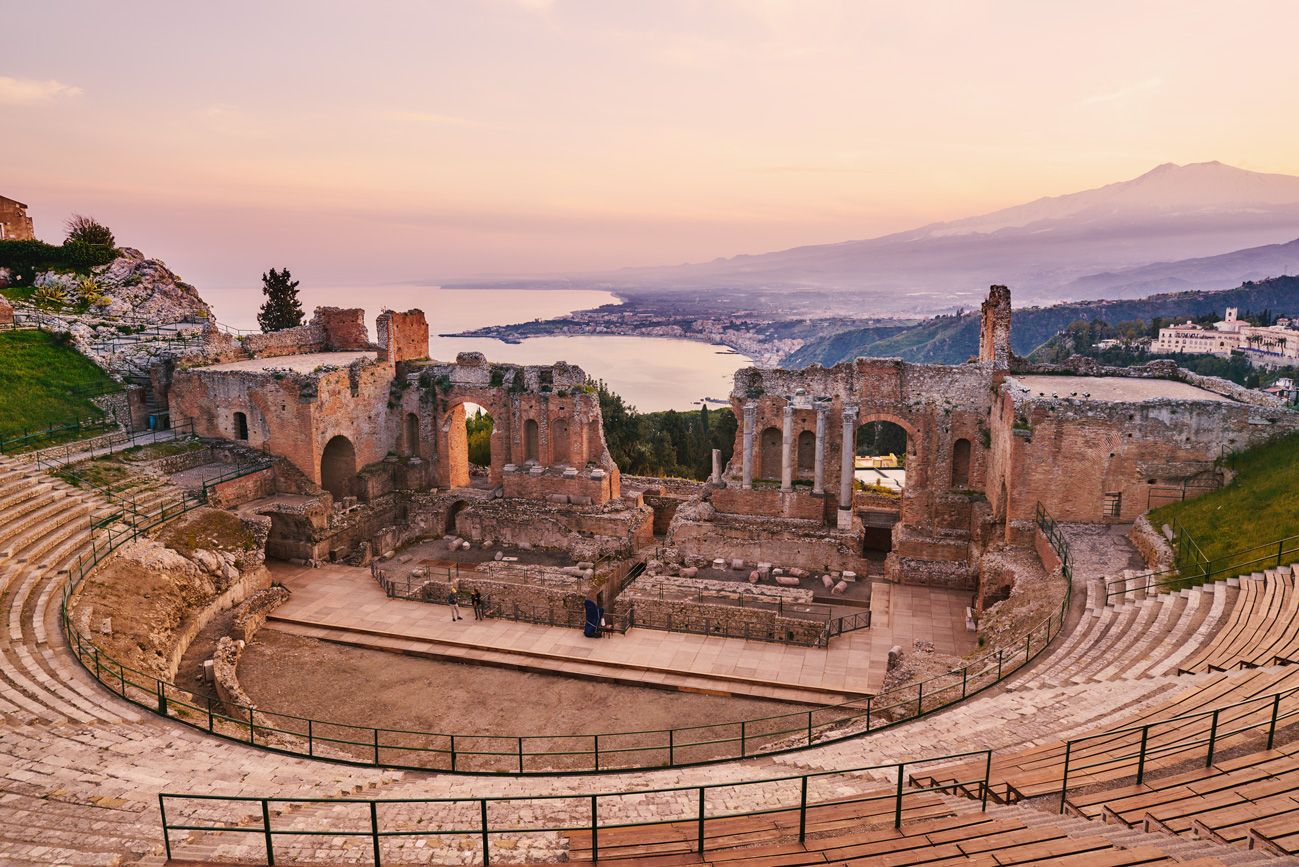What do you think is going on in this snapshot? The image captures the grandeur of the ancient Greek theater in Taormina, Italy. The theater, a testament to the architectural prowess of the ancient Greeks, is nestled on a hillside, its stone structure weathered by time but still standing strong. The amphitheater's semi-circular rows of seats, once filled with spectators, now lie empty, their stone surfaces bearing the marks of centuries.

The theater's strategic location offers a breathtaking panorama of the Mediterranean Sea, its azure waters stretching out into the horizon. The sea's tranquil blue contrasts with the lush greenery of the surrounding landscape, creating a picturesque scene.

In the distance, the imposing silhouette of Mount Etna looms, its peak shrouded in a veil of mist. The mountain's presence adds a sense of awe-inspiring scale to the image, reminding viewers of nature's grandeur and power.

The photo is taken from a high vantage point, looking down on the theater and the landscape beyond. This perspective emphasizes the theater's circular layout and the vastness of the surrounding scenery. The image is a blend of history and nature, a snapshot of a place where the past and present coexist. 